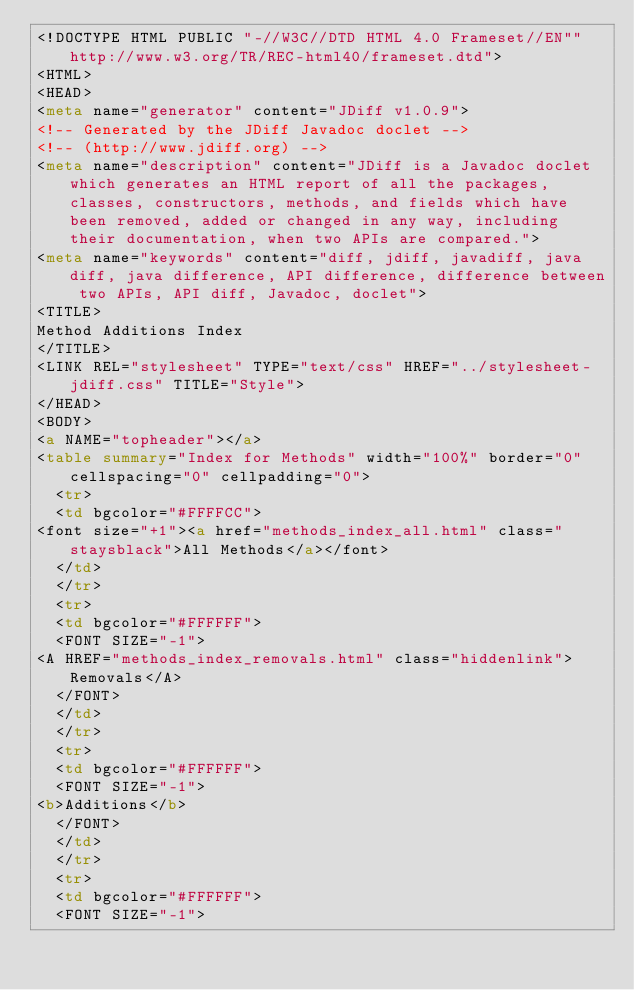<code> <loc_0><loc_0><loc_500><loc_500><_HTML_><!DOCTYPE HTML PUBLIC "-//W3C//DTD HTML 4.0 Frameset//EN""http://www.w3.org/TR/REC-html40/frameset.dtd">
<HTML>
<HEAD>
<meta name="generator" content="JDiff v1.0.9">
<!-- Generated by the JDiff Javadoc doclet -->
<!-- (http://www.jdiff.org) -->
<meta name="description" content="JDiff is a Javadoc doclet which generates an HTML report of all the packages, classes, constructors, methods, and fields which have been removed, added or changed in any way, including their documentation, when two APIs are compared.">
<meta name="keywords" content="diff, jdiff, javadiff, java diff, java difference, API difference, difference between two APIs, API diff, Javadoc, doclet">
<TITLE>
Method Additions Index
</TITLE>
<LINK REL="stylesheet" TYPE="text/css" HREF="../stylesheet-jdiff.css" TITLE="Style">
</HEAD>
<BODY>
<a NAME="topheader"></a>
<table summary="Index for Methods" width="100%" border="0" cellspacing="0" cellpadding="0">
  <tr>
  <td bgcolor="#FFFFCC">
<font size="+1"><a href="methods_index_all.html" class="staysblack">All Methods</a></font>
  </td>
  </tr>
  <tr>
  <td bgcolor="#FFFFFF">
  <FONT SIZE="-1">
<A HREF="methods_index_removals.html" class="hiddenlink">Removals</A>
  </FONT>
  </td>
  </tr>
  <tr>
  <td bgcolor="#FFFFFF">
  <FONT SIZE="-1">
<b>Additions</b>
  </FONT>
  </td>
  </tr>
  <tr>
  <td bgcolor="#FFFFFF">
  <FONT SIZE="-1"></code> 